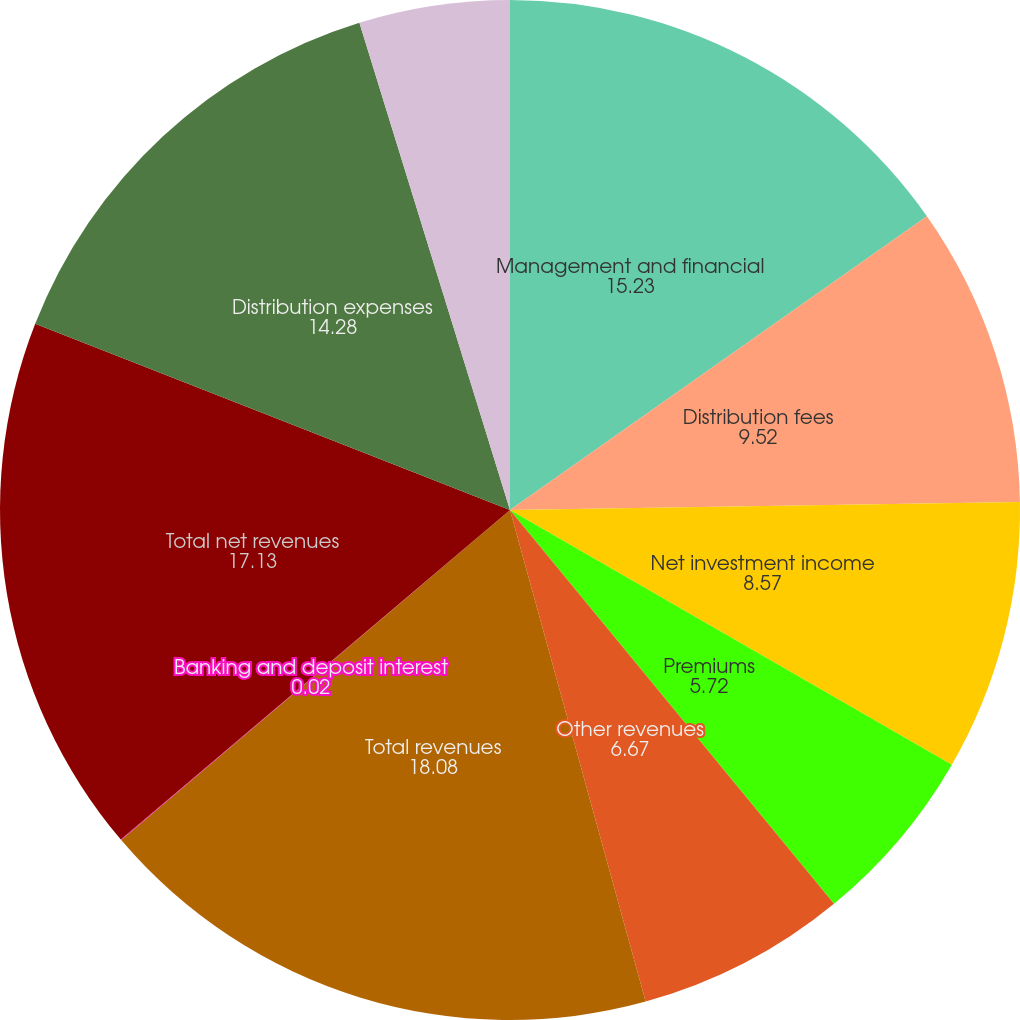Convert chart. <chart><loc_0><loc_0><loc_500><loc_500><pie_chart><fcel>Management and financial<fcel>Distribution fees<fcel>Net investment income<fcel>Premiums<fcel>Other revenues<fcel>Total revenues<fcel>Banking and deposit interest<fcel>Total net revenues<fcel>Distribution expenses<fcel>Interest credited to fixed<nl><fcel>15.23%<fcel>9.52%<fcel>8.57%<fcel>5.72%<fcel>6.67%<fcel>18.08%<fcel>0.02%<fcel>17.13%<fcel>14.28%<fcel>4.77%<nl></chart> 